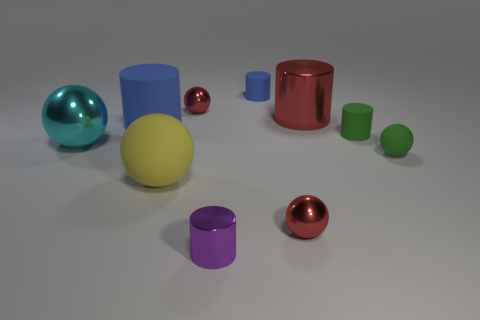Subtract all red cylinders. How many cylinders are left? 4 Subtract 2 spheres. How many spheres are left? 3 Subtract all cyan balls. How many balls are left? 4 Subtract all red cylinders. Subtract all purple spheres. How many cylinders are left? 4 Subtract all large cylinders. Subtract all large red metal things. How many objects are left? 7 Add 7 blue rubber objects. How many blue rubber objects are left? 9 Add 8 large metallic blocks. How many large metallic blocks exist? 8 Subtract 0 cyan cylinders. How many objects are left? 10 